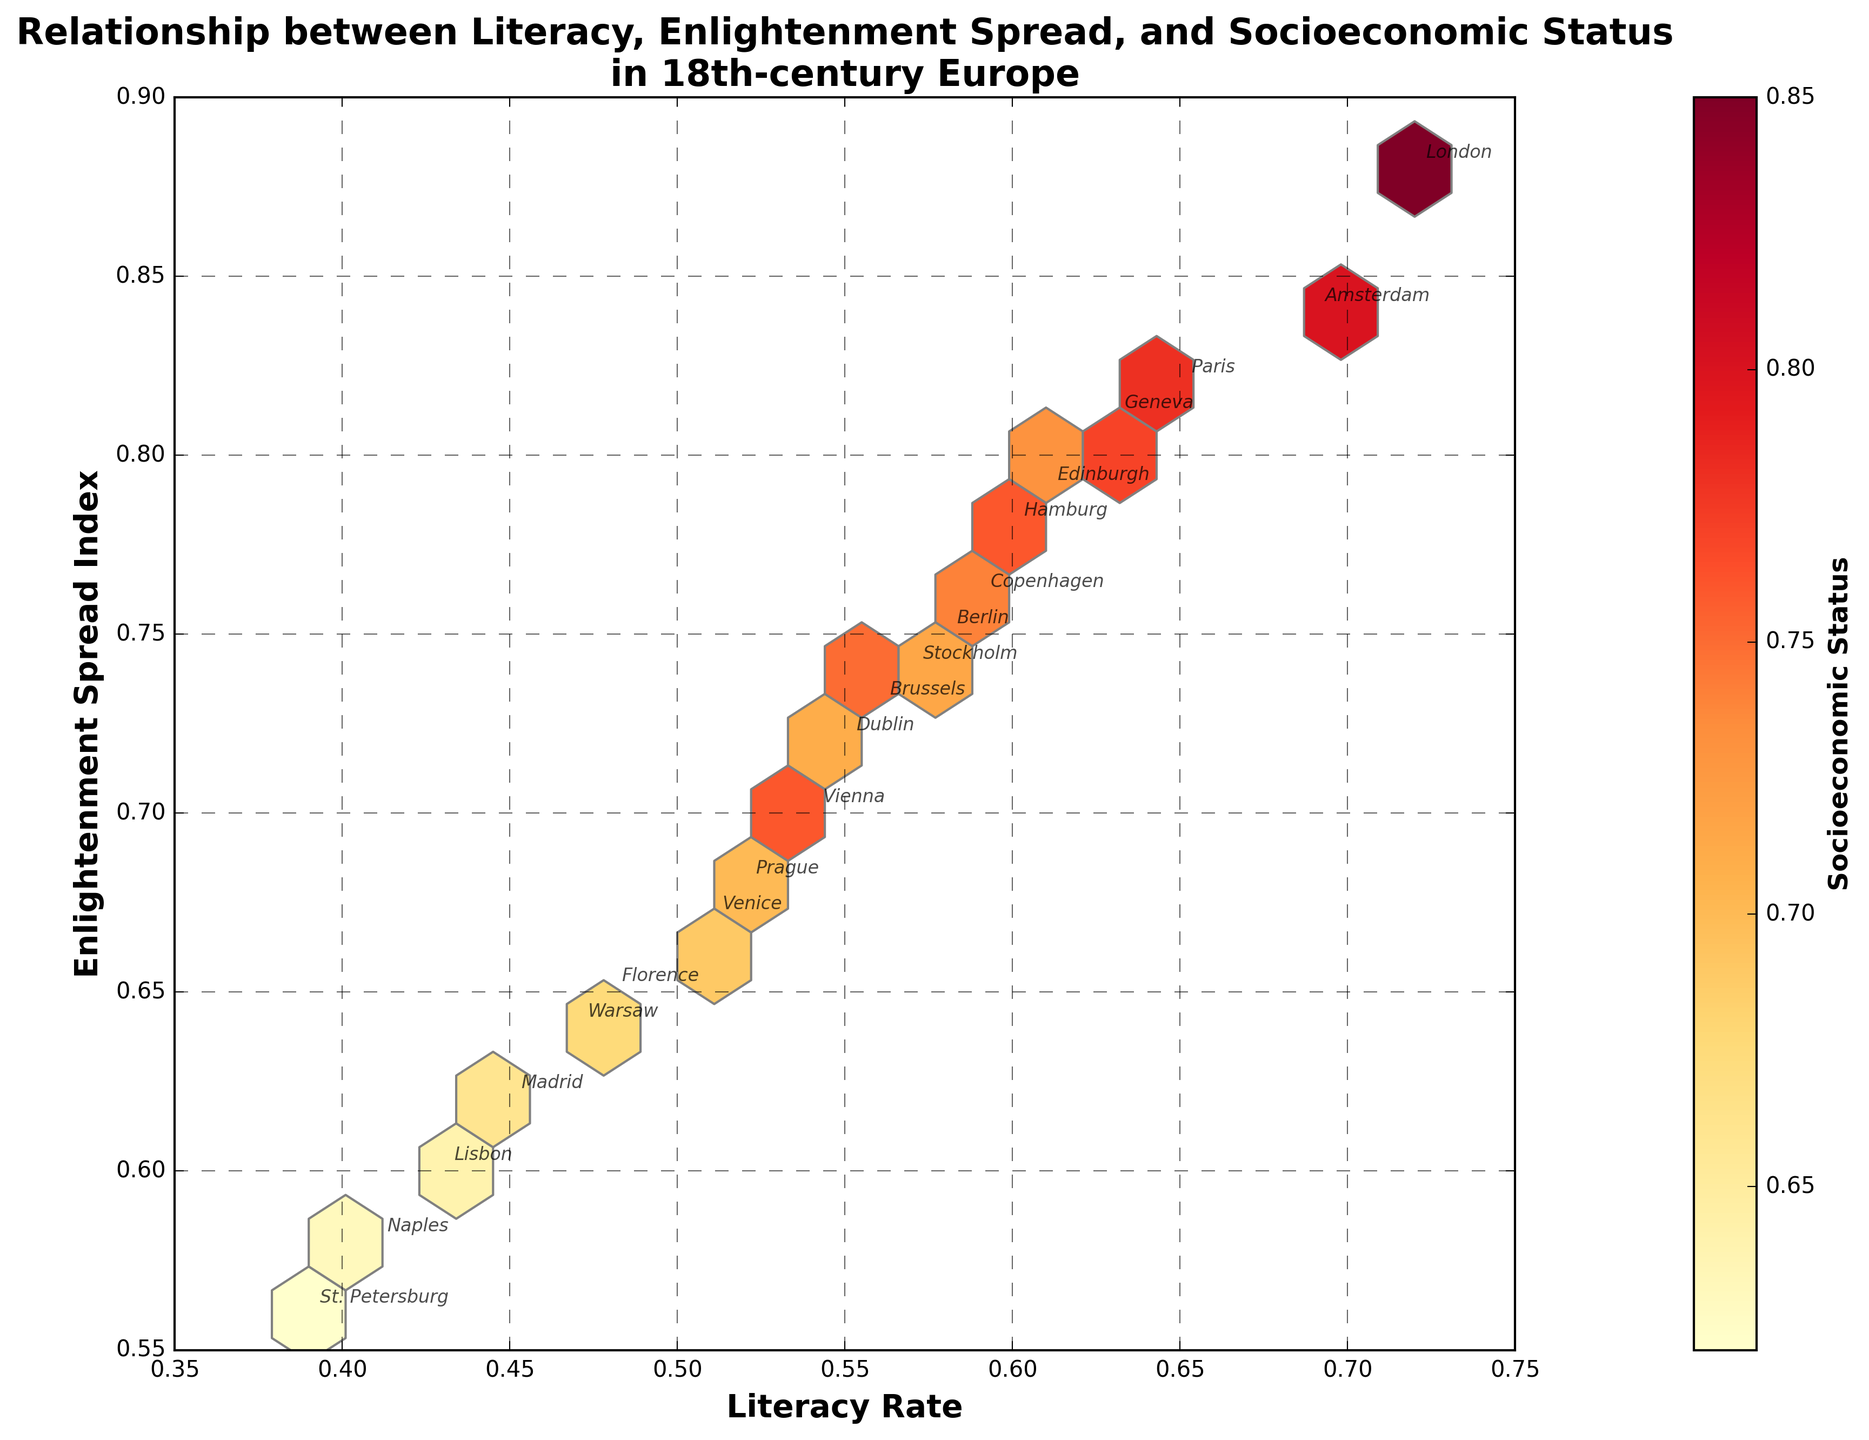What is the title of the figure? The title is at the top of the figure. It reads "Relationship between Literacy, Enlightenment Spread, and Socioeconomic Status in 18th-century Europe."
Answer: Relationship between Literacy, Enlightenment Spread, and Socioeconomic Status in 18th-century Europe How many hexagon bins are displayed in the plot? To find the number of hexagon bins, visually count the distinct hexagonal shapes within the plot.
Answer: 15 Which region has the highest literacy rate and what is that rate? Look for the data point furthest to the right on the x-axis (Literacy Rate). The annotated text near this point identifies the region as London, with a rate of 0.72.
Answer: London, 0.72 What does the color intensity in the hexagons represent? The color bar legend indicates that the color intensity represents Socioeconomic Status, ranging from lighter to darker shades.
Answer: Socioeconomic Status Which region has the lowest Enlightenment Spread Index? Find the data point lowest on the y-axis (Enlightenment Spread Index), identified as St. Petersburg with an index of 0.56.
Answer: St. Petersburg, 0.56 What is the socioeconomic status of Florence? Locate Florence on the plot. The color of the hexagon where Florence is placed shows its corresponding value on the color bar legend, which is approximately 0.68.
Answer: 0.68 Out of Paris and Berlin, which city has a higher literacy rate and by how much? Compare the x-values (Literacy Rate) of Paris and Berlin. Paris has a literacy rate of 0.65 and Berlin has 0.58. Subtract the smaller value from the larger value: 0.65 - 0.58.
Answer: Paris, by 0.07 What would be the average literacy rate of all cities displayed in the plot? Sum all the literacy rates and divide by the number of data points: (0.65 + 0.72 + 0.58 + 0.54 + 0.69 + 0.61 + 0.48 + 0.63 + 0.57 + 0.59 + 0.52 + 0.45 + 0.43 + 0.39 + 0.41 + 0.56 + 0.60 + 0.51 + 0.55 + 0.47) / 20. This gives (11.24 / 20).
Answer: 0.562 Is there a positive correlation between literacy rate and Enlightenment Spread Index? Observe the general trend as the literacy rate (x-axis) increases; the Enlightenment Spread Index (y-axis) also generally increases, indicating a positive correlation.
Answer: Yes Which region is an outlier in terms of both low literacy rate and low Enlightenment Spread Index? Locate the data point at the bottom left of the plot. St. Petersburg appears as an outlier with both low literacy rate (0.39) and low Enlightenment Spread Index (0.56).
Answer: St. Petersburg 